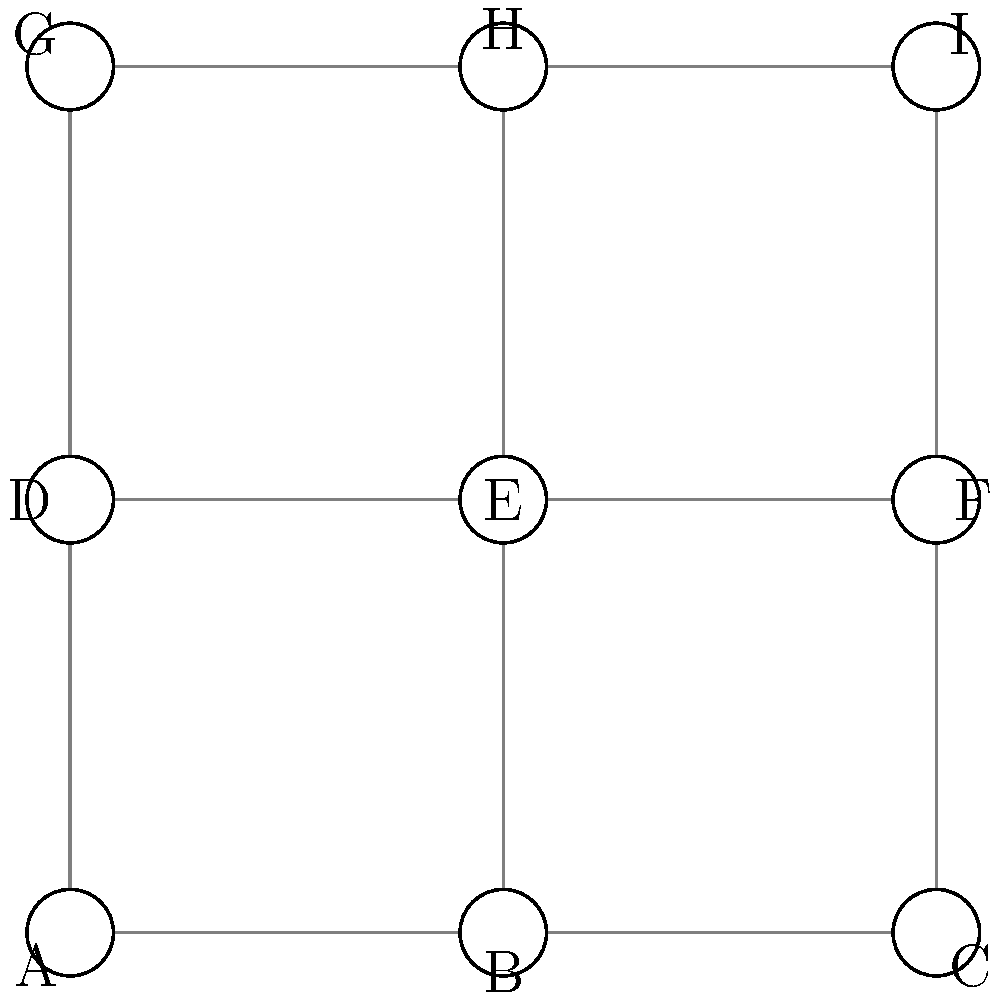Given the floor plan graph of a hospital wing represented above, where each vertex represents a room or intersection and each edge represents a corridor, determine the minimum number of hand sanitizer stations needed to ensure that every corridor (edge) has at least one station at one of its endpoints. Which vertices should be selected for placing the hand sanitizer stations? To solve this problem, we need to find the minimum vertex cover of the given graph. A vertex cover is a set of vertices such that each edge of the graph is incident to at least one vertex in the set. The minimum vertex cover represents the optimal placement of hand sanitizer stations.

Step 1: Analyze the graph structure.
The graph is a 3x3 grid with 9 vertices (A to I) and 12 edges.

Step 2: Identify the key vertices.
The corner vertices (A, C, G, I) cover only two edges each.
The side vertices (B, D, F, H) cover three edges each.
The center vertex (E) covers four edges.

Step 3: Find the minimum vertex cover.
To cover all edges efficiently, we need to select vertices that cover the maximum number of edges while minimizing overlap.

The optimal solution is to choose the four side vertices: B, D, F, and H.
- B covers edges AB, BC, and BE
- D covers edges AD, DE, and DG
- F covers edges CF, EF, and FI
- H covers edges EH, GH, and HI

This selection covers all 12 edges with only 4 vertices.

Step 4: Verify the solution.
Check that each edge is covered by at least one of the selected vertices:
AB (B), BC (B), AD (D), CF (F), GH (H), HI (H), BE (B), DE (D), EF (F), EH (H), DG (D), FI (F)

All edges are covered, confirming that this is a valid vertex cover.

Step 5: Prove minimality.
It's impossible to cover all edges with fewer than 4 vertices because:
- Selecting any 3 vertices would leave at least one edge uncovered.
- The 4 corner vertices (A, C, G, I) together cover only 8 out of 12 edges.
- Any combination of 3 side vertices (B, D, F, H) and the center vertex (E) would also leave at least one edge uncovered.

Therefore, 4 is the minimum number of vertices required for a complete vertex cover.
Answer: 4 stations at vertices B, D, F, and H 